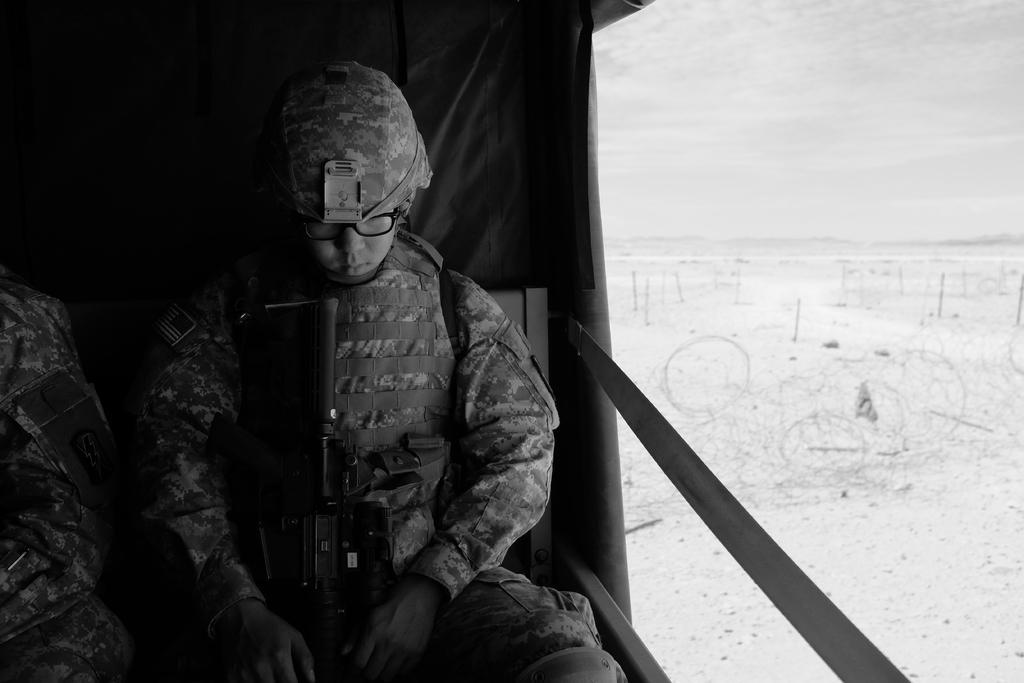How would you summarize this image in a sentence or two? This looks like a black and white image. I can see two people sitting in a vehicle. I think this is a weapon. This is the sky. 